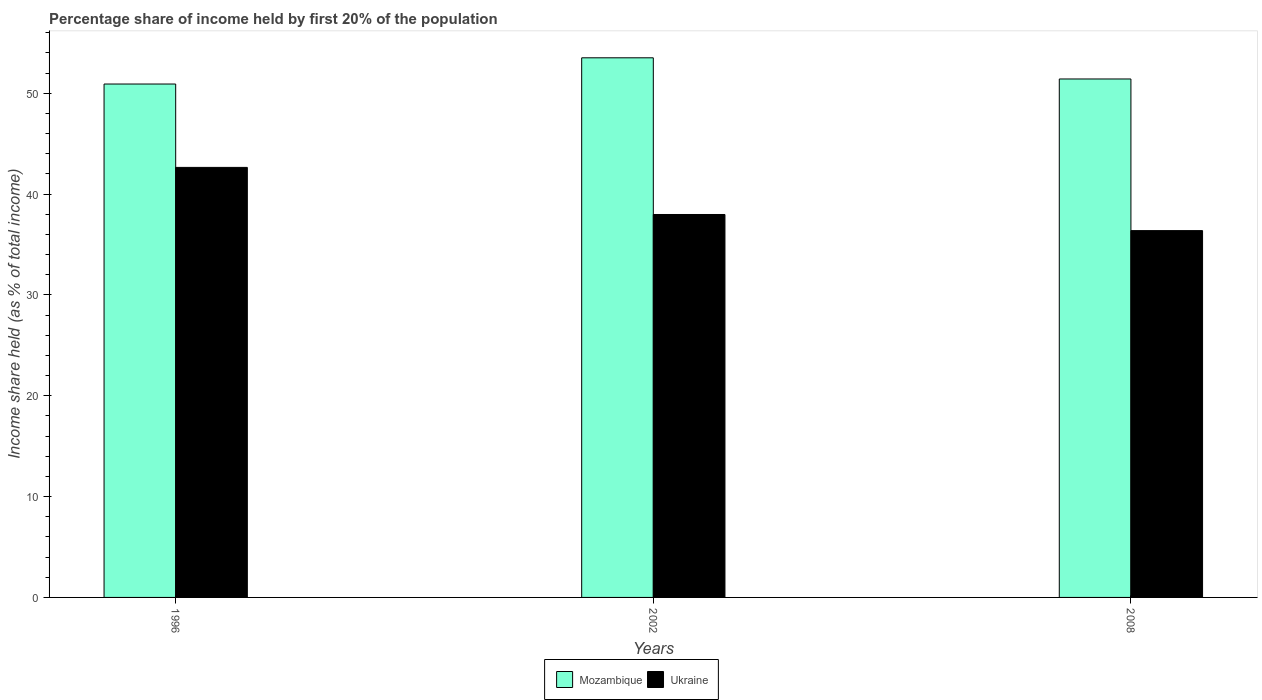How many groups of bars are there?
Your answer should be compact. 3. Are the number of bars on each tick of the X-axis equal?
Provide a short and direct response. Yes. In how many cases, is the number of bars for a given year not equal to the number of legend labels?
Offer a terse response. 0. What is the share of income held by first 20% of the population in Mozambique in 2002?
Make the answer very short. 53.52. Across all years, what is the maximum share of income held by first 20% of the population in Ukraine?
Your answer should be compact. 42.65. Across all years, what is the minimum share of income held by first 20% of the population in Mozambique?
Provide a short and direct response. 50.92. What is the total share of income held by first 20% of the population in Ukraine in the graph?
Keep it short and to the point. 117.01. What is the difference between the share of income held by first 20% of the population in Ukraine in 2002 and that in 2008?
Ensure brevity in your answer.  1.6. What is the difference between the share of income held by first 20% of the population in Mozambique in 2008 and the share of income held by first 20% of the population in Ukraine in 1996?
Give a very brief answer. 8.77. What is the average share of income held by first 20% of the population in Mozambique per year?
Keep it short and to the point. 51.95. In the year 1996, what is the difference between the share of income held by first 20% of the population in Mozambique and share of income held by first 20% of the population in Ukraine?
Give a very brief answer. 8.27. What is the ratio of the share of income held by first 20% of the population in Mozambique in 1996 to that in 2008?
Your response must be concise. 0.99. Is the share of income held by first 20% of the population in Mozambique in 1996 less than that in 2002?
Your answer should be compact. Yes. What is the difference between the highest and the second highest share of income held by first 20% of the population in Ukraine?
Ensure brevity in your answer.  4.67. What is the difference between the highest and the lowest share of income held by first 20% of the population in Mozambique?
Offer a very short reply. 2.6. What does the 1st bar from the left in 1996 represents?
Give a very brief answer. Mozambique. What does the 2nd bar from the right in 2002 represents?
Ensure brevity in your answer.  Mozambique. How many bars are there?
Your answer should be compact. 6. What is the difference between two consecutive major ticks on the Y-axis?
Provide a short and direct response. 10. Does the graph contain any zero values?
Provide a succinct answer. No. Does the graph contain grids?
Your answer should be compact. No. How many legend labels are there?
Your response must be concise. 2. How are the legend labels stacked?
Provide a succinct answer. Horizontal. What is the title of the graph?
Offer a very short reply. Percentage share of income held by first 20% of the population. Does "Panama" appear as one of the legend labels in the graph?
Your answer should be very brief. No. What is the label or title of the X-axis?
Make the answer very short. Years. What is the label or title of the Y-axis?
Your answer should be compact. Income share held (as % of total income). What is the Income share held (as % of total income) of Mozambique in 1996?
Your answer should be very brief. 50.92. What is the Income share held (as % of total income) in Ukraine in 1996?
Offer a terse response. 42.65. What is the Income share held (as % of total income) in Mozambique in 2002?
Provide a short and direct response. 53.52. What is the Income share held (as % of total income) of Ukraine in 2002?
Make the answer very short. 37.98. What is the Income share held (as % of total income) in Mozambique in 2008?
Offer a terse response. 51.42. What is the Income share held (as % of total income) in Ukraine in 2008?
Offer a terse response. 36.38. Across all years, what is the maximum Income share held (as % of total income) in Mozambique?
Offer a terse response. 53.52. Across all years, what is the maximum Income share held (as % of total income) of Ukraine?
Offer a very short reply. 42.65. Across all years, what is the minimum Income share held (as % of total income) of Mozambique?
Offer a terse response. 50.92. Across all years, what is the minimum Income share held (as % of total income) in Ukraine?
Offer a terse response. 36.38. What is the total Income share held (as % of total income) in Mozambique in the graph?
Give a very brief answer. 155.86. What is the total Income share held (as % of total income) in Ukraine in the graph?
Offer a terse response. 117.01. What is the difference between the Income share held (as % of total income) in Ukraine in 1996 and that in 2002?
Provide a succinct answer. 4.67. What is the difference between the Income share held (as % of total income) in Ukraine in 1996 and that in 2008?
Keep it short and to the point. 6.27. What is the difference between the Income share held (as % of total income) in Mozambique in 2002 and that in 2008?
Provide a short and direct response. 2.1. What is the difference between the Income share held (as % of total income) in Ukraine in 2002 and that in 2008?
Provide a succinct answer. 1.6. What is the difference between the Income share held (as % of total income) of Mozambique in 1996 and the Income share held (as % of total income) of Ukraine in 2002?
Offer a terse response. 12.94. What is the difference between the Income share held (as % of total income) in Mozambique in 1996 and the Income share held (as % of total income) in Ukraine in 2008?
Give a very brief answer. 14.54. What is the difference between the Income share held (as % of total income) of Mozambique in 2002 and the Income share held (as % of total income) of Ukraine in 2008?
Your response must be concise. 17.14. What is the average Income share held (as % of total income) in Mozambique per year?
Provide a succinct answer. 51.95. What is the average Income share held (as % of total income) in Ukraine per year?
Offer a very short reply. 39. In the year 1996, what is the difference between the Income share held (as % of total income) in Mozambique and Income share held (as % of total income) in Ukraine?
Give a very brief answer. 8.27. In the year 2002, what is the difference between the Income share held (as % of total income) of Mozambique and Income share held (as % of total income) of Ukraine?
Ensure brevity in your answer.  15.54. In the year 2008, what is the difference between the Income share held (as % of total income) of Mozambique and Income share held (as % of total income) of Ukraine?
Give a very brief answer. 15.04. What is the ratio of the Income share held (as % of total income) in Mozambique in 1996 to that in 2002?
Provide a short and direct response. 0.95. What is the ratio of the Income share held (as % of total income) of Ukraine in 1996 to that in 2002?
Keep it short and to the point. 1.12. What is the ratio of the Income share held (as % of total income) of Mozambique in 1996 to that in 2008?
Offer a very short reply. 0.99. What is the ratio of the Income share held (as % of total income) in Ukraine in 1996 to that in 2008?
Give a very brief answer. 1.17. What is the ratio of the Income share held (as % of total income) in Mozambique in 2002 to that in 2008?
Keep it short and to the point. 1.04. What is the ratio of the Income share held (as % of total income) in Ukraine in 2002 to that in 2008?
Keep it short and to the point. 1.04. What is the difference between the highest and the second highest Income share held (as % of total income) in Ukraine?
Keep it short and to the point. 4.67. What is the difference between the highest and the lowest Income share held (as % of total income) in Ukraine?
Provide a short and direct response. 6.27. 